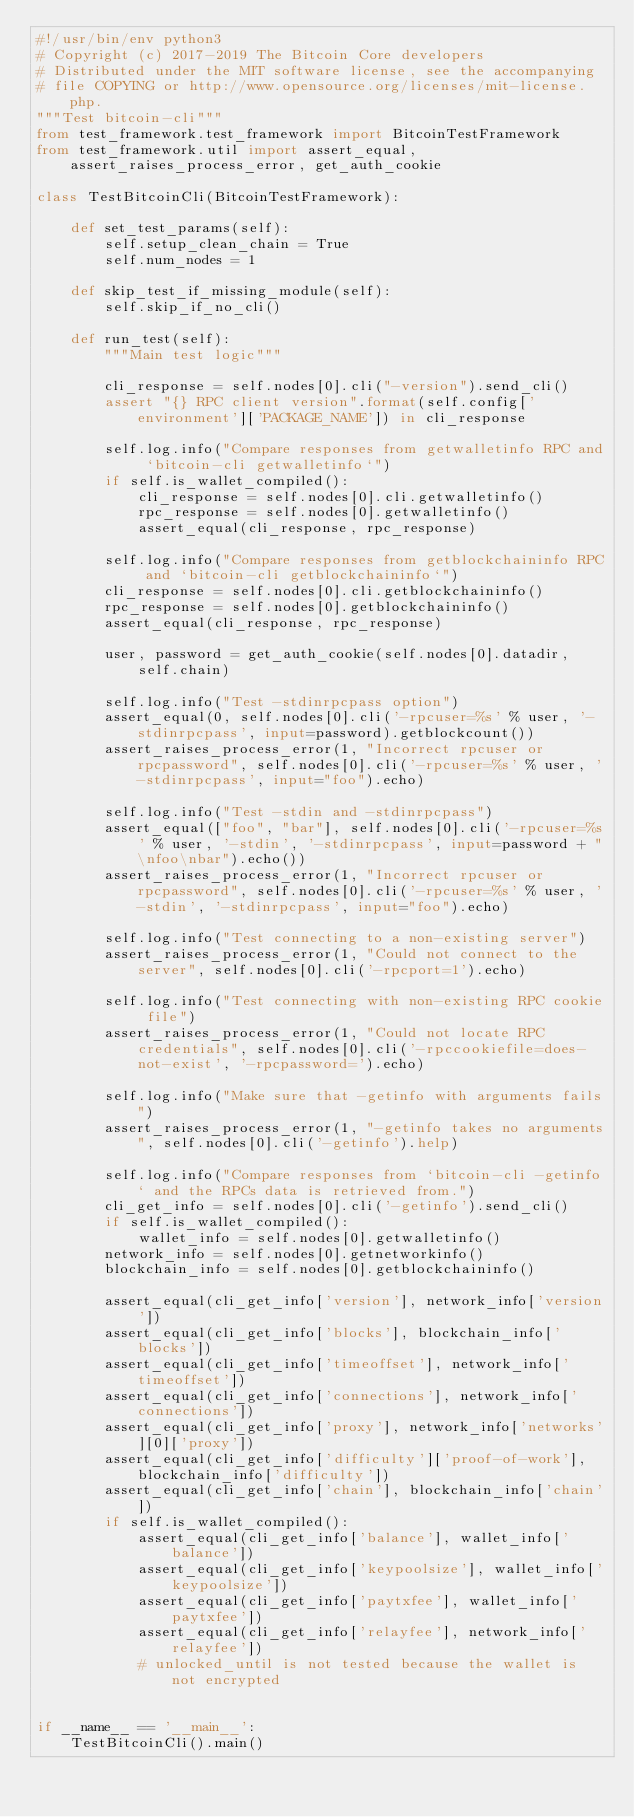<code> <loc_0><loc_0><loc_500><loc_500><_Python_>#!/usr/bin/env python3
# Copyright (c) 2017-2019 The Bitcoin Core developers
# Distributed under the MIT software license, see the accompanying
# file COPYING or http://www.opensource.org/licenses/mit-license.php.
"""Test bitcoin-cli"""
from test_framework.test_framework import BitcoinTestFramework
from test_framework.util import assert_equal, assert_raises_process_error, get_auth_cookie

class TestBitcoinCli(BitcoinTestFramework):

    def set_test_params(self):
        self.setup_clean_chain = True
        self.num_nodes = 1

    def skip_test_if_missing_module(self):
        self.skip_if_no_cli()

    def run_test(self):
        """Main test logic"""

        cli_response = self.nodes[0].cli("-version").send_cli()
        assert "{} RPC client version".format(self.config['environment']['PACKAGE_NAME']) in cli_response

        self.log.info("Compare responses from getwalletinfo RPC and `bitcoin-cli getwalletinfo`")
        if self.is_wallet_compiled():
            cli_response = self.nodes[0].cli.getwalletinfo()
            rpc_response = self.nodes[0].getwalletinfo()
            assert_equal(cli_response, rpc_response)

        self.log.info("Compare responses from getblockchaininfo RPC and `bitcoin-cli getblockchaininfo`")
        cli_response = self.nodes[0].cli.getblockchaininfo()
        rpc_response = self.nodes[0].getblockchaininfo()
        assert_equal(cli_response, rpc_response)

        user, password = get_auth_cookie(self.nodes[0].datadir, self.chain)

        self.log.info("Test -stdinrpcpass option")
        assert_equal(0, self.nodes[0].cli('-rpcuser=%s' % user, '-stdinrpcpass', input=password).getblockcount())
        assert_raises_process_error(1, "Incorrect rpcuser or rpcpassword", self.nodes[0].cli('-rpcuser=%s' % user, '-stdinrpcpass', input="foo").echo)

        self.log.info("Test -stdin and -stdinrpcpass")
        assert_equal(["foo", "bar"], self.nodes[0].cli('-rpcuser=%s' % user, '-stdin', '-stdinrpcpass', input=password + "\nfoo\nbar").echo())
        assert_raises_process_error(1, "Incorrect rpcuser or rpcpassword", self.nodes[0].cli('-rpcuser=%s' % user, '-stdin', '-stdinrpcpass', input="foo").echo)

        self.log.info("Test connecting to a non-existing server")
        assert_raises_process_error(1, "Could not connect to the server", self.nodes[0].cli('-rpcport=1').echo)

        self.log.info("Test connecting with non-existing RPC cookie file")
        assert_raises_process_error(1, "Could not locate RPC credentials", self.nodes[0].cli('-rpccookiefile=does-not-exist', '-rpcpassword=').echo)

        self.log.info("Make sure that -getinfo with arguments fails")
        assert_raises_process_error(1, "-getinfo takes no arguments", self.nodes[0].cli('-getinfo').help)

        self.log.info("Compare responses from `bitcoin-cli -getinfo` and the RPCs data is retrieved from.")
        cli_get_info = self.nodes[0].cli('-getinfo').send_cli()
        if self.is_wallet_compiled():
            wallet_info = self.nodes[0].getwalletinfo()
        network_info = self.nodes[0].getnetworkinfo()
        blockchain_info = self.nodes[0].getblockchaininfo()

        assert_equal(cli_get_info['version'], network_info['version'])
        assert_equal(cli_get_info['blocks'], blockchain_info['blocks'])
        assert_equal(cli_get_info['timeoffset'], network_info['timeoffset'])
        assert_equal(cli_get_info['connections'], network_info['connections'])
        assert_equal(cli_get_info['proxy'], network_info['networks'][0]['proxy'])
        assert_equal(cli_get_info['difficulty']['proof-of-work'], blockchain_info['difficulty'])
        assert_equal(cli_get_info['chain'], blockchain_info['chain'])
        if self.is_wallet_compiled():
            assert_equal(cli_get_info['balance'], wallet_info['balance'])
            assert_equal(cli_get_info['keypoolsize'], wallet_info['keypoolsize'])
            assert_equal(cli_get_info['paytxfee'], wallet_info['paytxfee'])
            assert_equal(cli_get_info['relayfee'], network_info['relayfee'])
            # unlocked_until is not tested because the wallet is not encrypted


if __name__ == '__main__':
    TestBitcoinCli().main()
</code> 